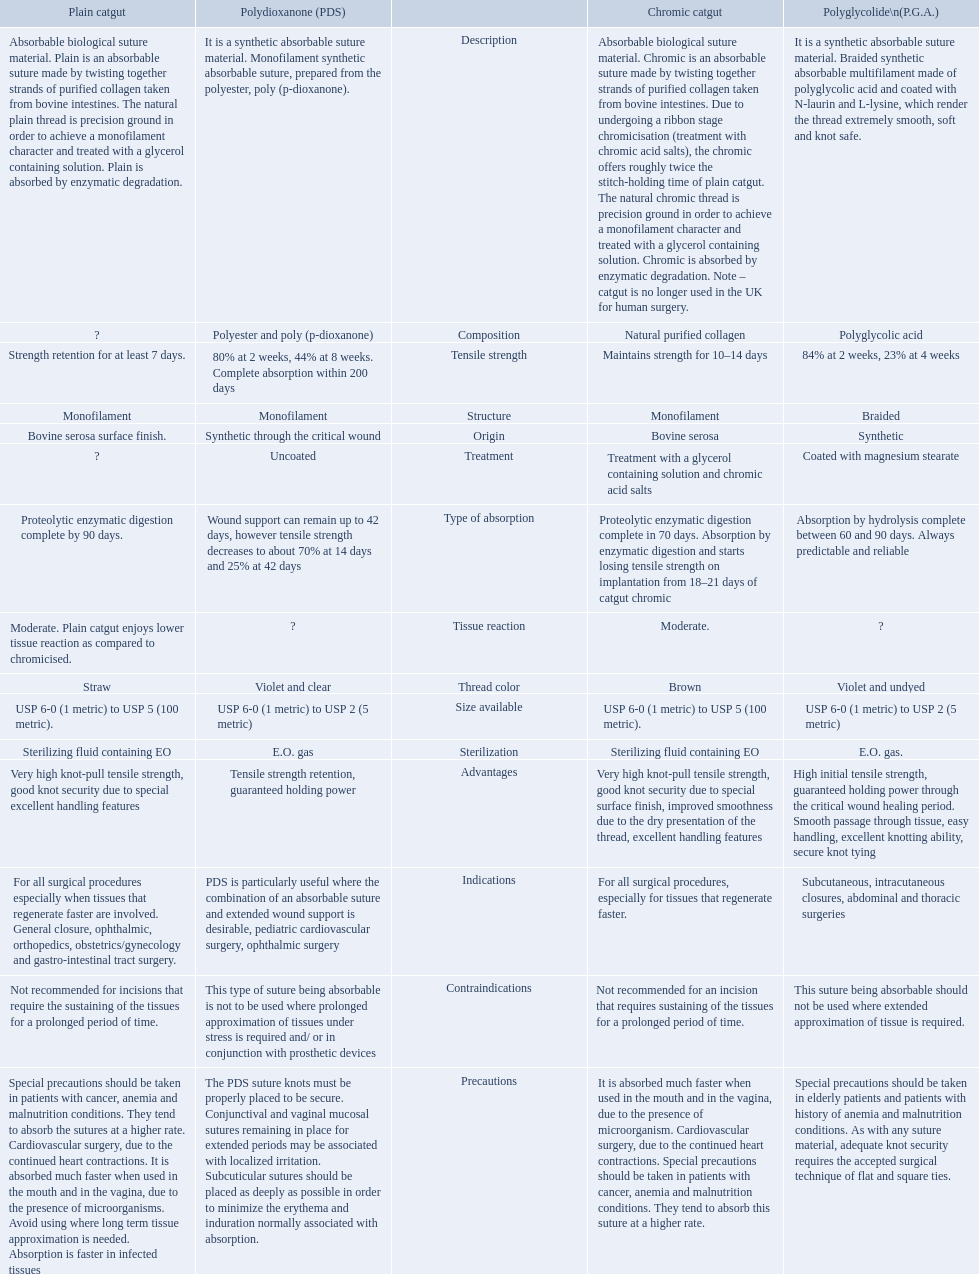What categories are listed in the suture materials comparison chart? Description, Composition, Tensile strength, Structure, Origin, Treatment, Type of absorption, Tissue reaction, Thread color, Size available, Sterilization, Advantages, Indications, Contraindications, Precautions. Can you give me this table as a dict? {'header': ['Plain catgut', 'Polydioxanone (PDS)', '', 'Chromic catgut', 'Polyglycolide\\n(P.G.A.)'], 'rows': [['Absorbable biological suture material. Plain is an absorbable suture made by twisting together strands of purified collagen taken from bovine intestines. The natural plain thread is precision ground in order to achieve a monofilament character and treated with a glycerol containing solution. Plain is absorbed by enzymatic degradation.', 'It is a synthetic absorbable suture material. Monofilament synthetic absorbable suture, prepared from the polyester, poly (p-dioxanone).', 'Description', 'Absorbable biological suture material. Chromic is an absorbable suture made by twisting together strands of purified collagen taken from bovine intestines. Due to undergoing a ribbon stage chromicisation (treatment with chromic acid salts), the chromic offers roughly twice the stitch-holding time of plain catgut. The natural chromic thread is precision ground in order to achieve a monofilament character and treated with a glycerol containing solution. Chromic is absorbed by enzymatic degradation. Note – catgut is no longer used in the UK for human surgery.', 'It is a synthetic absorbable suture material. Braided synthetic absorbable multifilament made of polyglycolic acid and coated with N-laurin and L-lysine, which render the thread extremely smooth, soft and knot safe.'], ['?', 'Polyester and poly (p-dioxanone)', 'Composition', 'Natural purified collagen', 'Polyglycolic acid'], ['Strength retention for at least 7 days.', '80% at 2 weeks, 44% at 8 weeks. Complete absorption within 200 days', 'Tensile strength', 'Maintains strength for 10–14 days', '84% at 2 weeks, 23% at 4 weeks'], ['Monofilament', 'Monofilament', 'Structure', 'Monofilament', 'Braided'], ['Bovine serosa surface finish.', 'Synthetic through the critical wound', 'Origin', 'Bovine serosa', 'Synthetic'], ['?', 'Uncoated', 'Treatment', 'Treatment with a glycerol containing solution and chromic acid salts', 'Coated with magnesium stearate'], ['Proteolytic enzymatic digestion complete by 90 days.', 'Wound support can remain up to 42 days, however tensile strength decreases to about 70% at 14 days and 25% at 42 days', 'Type of absorption', 'Proteolytic enzymatic digestion complete in 70 days. Absorption by enzymatic digestion and starts losing tensile strength on implantation from 18–21 days of catgut chromic', 'Absorption by hydrolysis complete between 60 and 90 days. Always predictable and reliable'], ['Moderate. Plain catgut enjoys lower tissue reaction as compared to chromicised.', '?', 'Tissue reaction', 'Moderate.', '?'], ['Straw', 'Violet and clear', 'Thread color', 'Brown', 'Violet and undyed'], ['USP 6-0 (1 metric) to USP 5 (100 metric).', 'USP 6-0 (1 metric) to USP 2 (5 metric)', 'Size available', 'USP 6-0 (1 metric) to USP 5 (100 metric).', 'USP 6-0 (1 metric) to USP 2 (5 metric)'], ['Sterilizing fluid containing EO', 'E.O. gas', 'Sterilization', 'Sterilizing fluid containing EO', 'E.O. gas.'], ['Very high knot-pull tensile strength, good knot security due to special excellent handling features', 'Tensile strength retention, guaranteed holding power', 'Advantages', 'Very high knot-pull tensile strength, good knot security due to special surface finish, improved smoothness due to the dry presentation of the thread, excellent handling features', 'High initial tensile strength, guaranteed holding power through the critical wound healing period. Smooth passage through tissue, easy handling, excellent knotting ability, secure knot tying'], ['For all surgical procedures especially when tissues that regenerate faster are involved. General closure, ophthalmic, orthopedics, obstetrics/gynecology and gastro-intestinal tract surgery.', 'PDS is particularly useful where the combination of an absorbable suture and extended wound support is desirable, pediatric cardiovascular surgery, ophthalmic surgery', 'Indications', 'For all surgical procedures, especially for tissues that regenerate faster.', 'Subcutaneous, intracutaneous closures, abdominal and thoracic surgeries'], ['Not recommended for incisions that require the sustaining of the tissues for a prolonged period of time.', 'This type of suture being absorbable is not to be used where prolonged approximation of tissues under stress is required and/ or in conjunction with prosthetic devices', 'Contraindications', 'Not recommended for an incision that requires sustaining of the tissues for a prolonged period of time.', 'This suture being absorbable should not be used where extended approximation of tissue is required.'], ['Special precautions should be taken in patients with cancer, anemia and malnutrition conditions. They tend to absorb the sutures at a higher rate. Cardiovascular surgery, due to the continued heart contractions. It is absorbed much faster when used in the mouth and in the vagina, due to the presence of microorganisms. Avoid using where long term tissue approximation is needed. Absorption is faster in infected tissues', 'The PDS suture knots must be properly placed to be secure. Conjunctival and vaginal mucosal sutures remaining in place for extended periods may be associated with localized irritation. Subcuticular sutures should be placed as deeply as possible in order to minimize the erythema and induration normally associated with absorption.', 'Precautions', 'It is absorbed much faster when used in the mouth and in the vagina, due to the presence of microorganism. Cardiovascular surgery, due to the continued heart contractions. Special precautions should be taken in patients with cancer, anemia and malnutrition conditions. They tend to absorb this suture at a higher rate.', 'Special precautions should be taken in elderly patients and patients with history of anemia and malnutrition conditions. As with any suture material, adequate knot security requires the accepted surgical technique of flat and square ties.']]} Of the testile strength, which is the lowest? Strength retention for at least 7 days. 